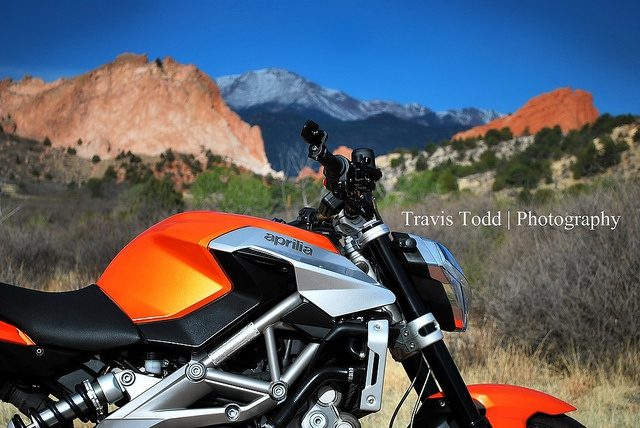Describe the objects in this image and their specific colors. I can see a motorcycle in darkblue, black, gray, white, and red tones in this image. 